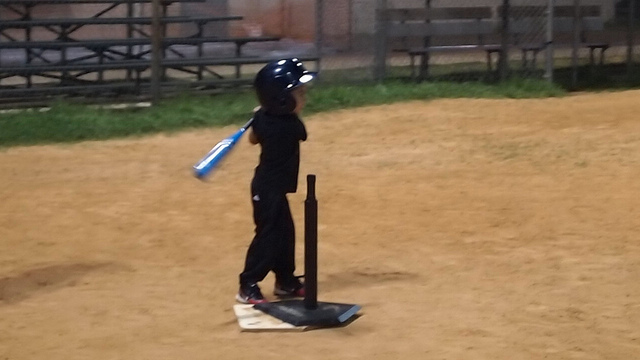What might this child be dreaming about while standing at the plate? The child might be dreaming about hitting a game-winning home run, just like their baseball heroes. They could be imagining the cheers of the crowd, the satisfaction of a solid hit, and the thrill of running the bases, perhaps even in a stadium as grand as the ones where professional players like Pete Alonso compete. 